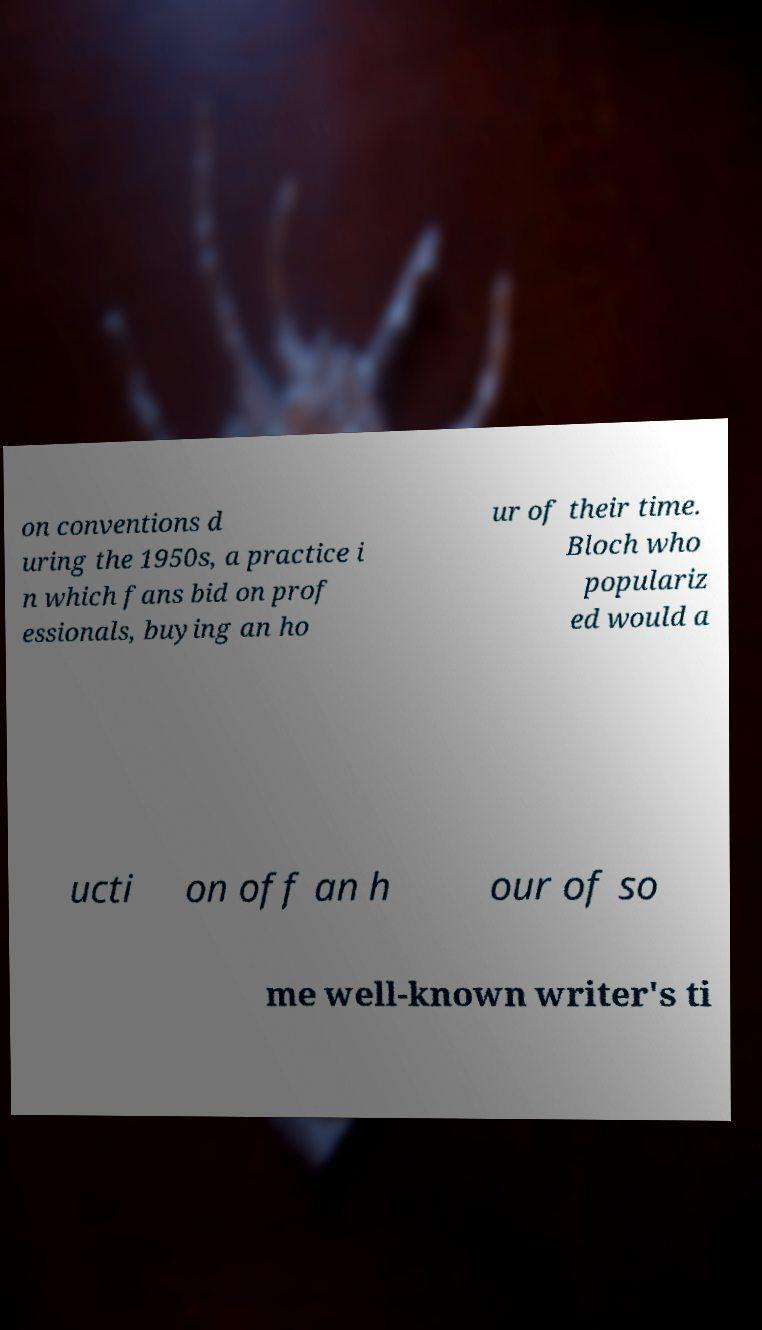For documentation purposes, I need the text within this image transcribed. Could you provide that? on conventions d uring the 1950s, a practice i n which fans bid on prof essionals, buying an ho ur of their time. Bloch who populariz ed would a ucti on off an h our of so me well-known writer's ti 